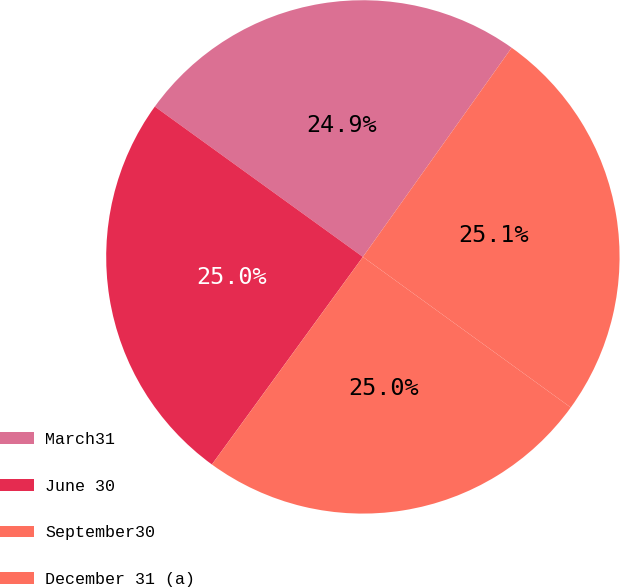Convert chart. <chart><loc_0><loc_0><loc_500><loc_500><pie_chart><fcel>March31<fcel>June 30<fcel>September30<fcel>December 31 (a)<nl><fcel>24.88%<fcel>24.95%<fcel>25.03%<fcel>25.14%<nl></chart> 